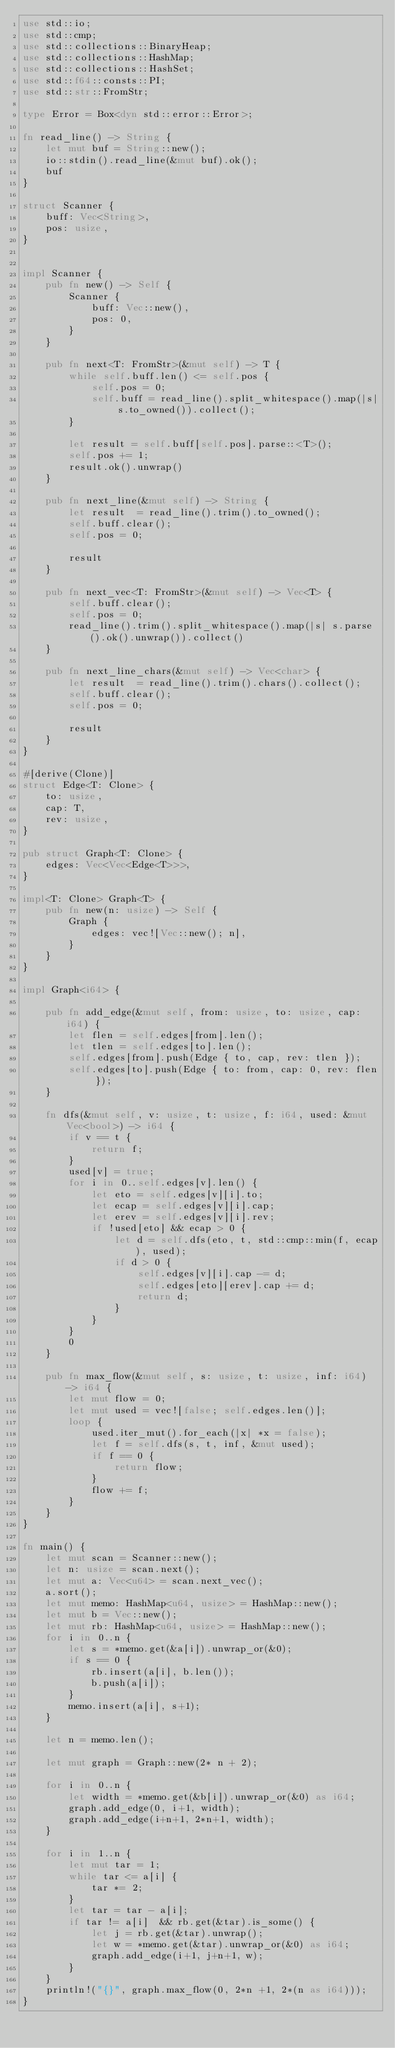<code> <loc_0><loc_0><loc_500><loc_500><_Rust_>use std::io;
use std::cmp;
use std::collections::BinaryHeap;
use std::collections::HashMap;
use std::collections::HashSet;
use std::f64::consts::PI;
use std::str::FromStr;

type Error = Box<dyn std::error::Error>;

fn read_line() -> String {
    let mut buf = String::new();
    io::stdin().read_line(&mut buf).ok();
    buf
}

struct Scanner {
    buff: Vec<String>,
    pos: usize,
}


impl Scanner {
    pub fn new() -> Self {
        Scanner {
            buff: Vec::new(),
            pos: 0,
        }
    }

    pub fn next<T: FromStr>(&mut self) -> T {
        while self.buff.len() <= self.pos {
            self.pos = 0;
            self.buff = read_line().split_whitespace().map(|s| s.to_owned()).collect();
        }

        let result = self.buff[self.pos].parse::<T>();
        self.pos += 1;
        result.ok().unwrap()
    }

    pub fn next_line(&mut self) -> String {
        let result  = read_line().trim().to_owned();
        self.buff.clear();
        self.pos = 0;

        result
    }

    pub fn next_vec<T: FromStr>(&mut self) -> Vec<T> {
        self.buff.clear();
        self.pos = 0;
        read_line().trim().split_whitespace().map(|s| s.parse().ok().unwrap()).collect()
    }
    
    pub fn next_line_chars(&mut self) -> Vec<char> {
        let result  = read_line().trim().chars().collect();
        self.buff.clear();
        self.pos = 0;

        result
    }
}

#[derive(Clone)]
struct Edge<T: Clone> {
    to: usize,
    cap: T,
    rev: usize,
}

pub struct Graph<T: Clone> {
    edges: Vec<Vec<Edge<T>>>,
}

impl<T: Clone> Graph<T> {
    pub fn new(n: usize) -> Self {
        Graph {
            edges: vec![Vec::new(); n],
        }
    }
}

impl Graph<i64> {

    pub fn add_edge(&mut self, from: usize, to: usize, cap: i64) {
        let flen = self.edges[from].len();
        let tlen = self.edges[to].len();
        self.edges[from].push(Edge { to, cap, rev: tlen });
        self.edges[to].push(Edge { to: from, cap: 0, rev: flen });
    }

    fn dfs(&mut self, v: usize, t: usize, f: i64, used: &mut Vec<bool>) -> i64 {
        if v == t {
            return f;
        }
        used[v] = true;
        for i in 0..self.edges[v].len() {
            let eto = self.edges[v][i].to;
            let ecap = self.edges[v][i].cap;
            let erev = self.edges[v][i].rev;
            if !used[eto] && ecap > 0 {
                let d = self.dfs(eto, t, std::cmp::min(f, ecap), used);
                if d > 0 {
                    self.edges[v][i].cap -= d;
                    self.edges[eto][erev].cap += d;
                    return d;
                }
            }
        }
        0
    }

    pub fn max_flow(&mut self, s: usize, t: usize, inf: i64) -> i64 {
        let mut flow = 0;
        let mut used = vec![false; self.edges.len()];
        loop {
            used.iter_mut().for_each(|x| *x = false);
            let f = self.dfs(s, t, inf, &mut used);
            if f == 0 {
                return flow;
            }
            flow += f;
        }
    }
}

fn main() {
    let mut scan = Scanner::new();
    let n: usize = scan.next();
    let mut a: Vec<u64> = scan.next_vec();
    a.sort();
    let mut memo: HashMap<u64, usize> = HashMap::new();
    let mut b = Vec::new();
    let mut rb: HashMap<u64, usize> = HashMap::new();
    for i in 0..n {
        let s = *memo.get(&a[i]).unwrap_or(&0);
        if s == 0 {
            rb.insert(a[i], b.len());
            b.push(a[i]);
        }
        memo.insert(a[i], s+1);
    }

    let n = memo.len();
    
    let mut graph = Graph::new(2* n + 2);

    for i in 0..n {
        let width = *memo.get(&b[i]).unwrap_or(&0) as i64;
        graph.add_edge(0, i+1, width);
        graph.add_edge(i+n+1, 2*n+1, width);
    }

    for i in 1..n {
        let mut tar = 1;
        while tar <= a[i] {
            tar *= 2;
        }
        let tar = tar - a[i];
        if tar != a[i]  && rb.get(&tar).is_some() {
            let j = rb.get(&tar).unwrap();
            let w = *memo.get(&tar).unwrap_or(&0) as i64;
            graph.add_edge(i+1, j+n+1, w);
        }
    }
    println!("{}", graph.max_flow(0, 2*n +1, 2*(n as i64)));
}
</code> 